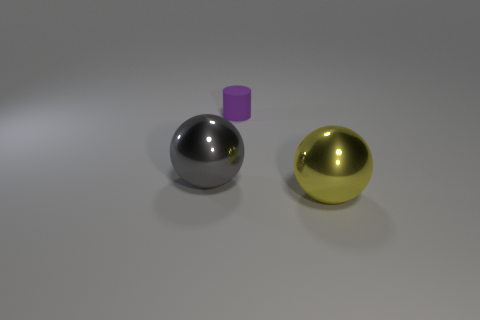Add 1 cyan balls. How many objects exist? 4 Subtract all cylinders. How many objects are left? 2 Add 3 red rubber things. How many red rubber things exist? 3 Subtract 0 green balls. How many objects are left? 3 Subtract all big yellow things. Subtract all cylinders. How many objects are left? 1 Add 3 metallic spheres. How many metallic spheres are left? 5 